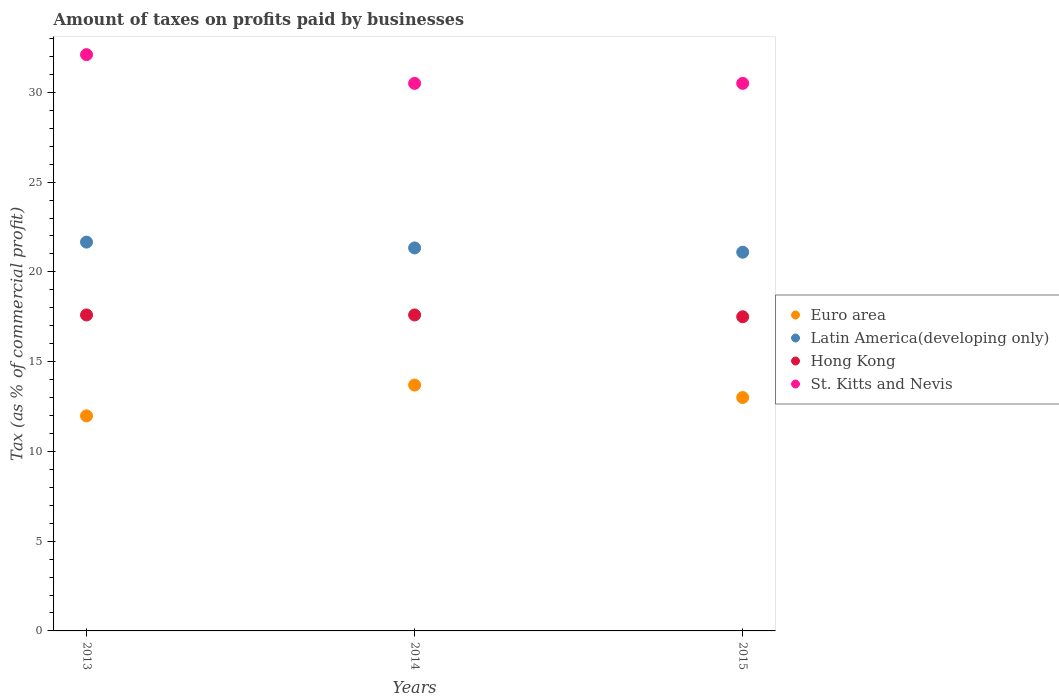Is the number of dotlines equal to the number of legend labels?
Offer a very short reply. Yes. Across all years, what is the maximum percentage of taxes paid by businesses in Latin America(developing only)?
Provide a succinct answer. 21.66. Across all years, what is the minimum percentage of taxes paid by businesses in Latin America(developing only)?
Provide a short and direct response. 21.1. In which year was the percentage of taxes paid by businesses in Latin America(developing only) maximum?
Your response must be concise. 2013. In which year was the percentage of taxes paid by businesses in Euro area minimum?
Offer a very short reply. 2013. What is the total percentage of taxes paid by businesses in Hong Kong in the graph?
Offer a very short reply. 52.7. What is the difference between the percentage of taxes paid by businesses in St. Kitts and Nevis in 2015 and the percentage of taxes paid by businesses in Latin America(developing only) in 2014?
Provide a short and direct response. 9.17. What is the average percentage of taxes paid by businesses in Hong Kong per year?
Offer a terse response. 17.57. In the year 2013, what is the difference between the percentage of taxes paid by businesses in Hong Kong and percentage of taxes paid by businesses in Euro area?
Your answer should be very brief. 5.62. In how many years, is the percentage of taxes paid by businesses in Euro area greater than 17 %?
Make the answer very short. 0. What is the ratio of the percentage of taxes paid by businesses in Hong Kong in 2014 to that in 2015?
Offer a very short reply. 1.01. Is the percentage of taxes paid by businesses in Hong Kong in 2013 less than that in 2014?
Ensure brevity in your answer.  No. What is the difference between the highest and the second highest percentage of taxes paid by businesses in Hong Kong?
Offer a terse response. 0. What is the difference between the highest and the lowest percentage of taxes paid by businesses in St. Kitts and Nevis?
Offer a very short reply. 1.6. In how many years, is the percentage of taxes paid by businesses in Hong Kong greater than the average percentage of taxes paid by businesses in Hong Kong taken over all years?
Provide a succinct answer. 2. Is it the case that in every year, the sum of the percentage of taxes paid by businesses in St. Kitts and Nevis and percentage of taxes paid by businesses in Hong Kong  is greater than the sum of percentage of taxes paid by businesses in Euro area and percentage of taxes paid by businesses in Latin America(developing only)?
Provide a short and direct response. Yes. How many dotlines are there?
Keep it short and to the point. 4. Does the graph contain grids?
Your response must be concise. No. How many legend labels are there?
Provide a short and direct response. 4. How are the legend labels stacked?
Provide a succinct answer. Vertical. What is the title of the graph?
Provide a short and direct response. Amount of taxes on profits paid by businesses. Does "Arab World" appear as one of the legend labels in the graph?
Your answer should be compact. No. What is the label or title of the Y-axis?
Make the answer very short. Tax (as % of commercial profit). What is the Tax (as % of commercial profit) in Euro area in 2013?
Offer a very short reply. 11.98. What is the Tax (as % of commercial profit) of Latin America(developing only) in 2013?
Provide a succinct answer. 21.66. What is the Tax (as % of commercial profit) of Hong Kong in 2013?
Your response must be concise. 17.6. What is the Tax (as % of commercial profit) of St. Kitts and Nevis in 2013?
Provide a succinct answer. 32.1. What is the Tax (as % of commercial profit) of Euro area in 2014?
Your answer should be compact. 13.69. What is the Tax (as % of commercial profit) of Latin America(developing only) in 2014?
Your response must be concise. 21.33. What is the Tax (as % of commercial profit) of St. Kitts and Nevis in 2014?
Your response must be concise. 30.5. What is the Tax (as % of commercial profit) of Euro area in 2015?
Your response must be concise. 13. What is the Tax (as % of commercial profit) in Latin America(developing only) in 2015?
Your answer should be compact. 21.1. What is the Tax (as % of commercial profit) of St. Kitts and Nevis in 2015?
Make the answer very short. 30.5. Across all years, what is the maximum Tax (as % of commercial profit) of Euro area?
Keep it short and to the point. 13.69. Across all years, what is the maximum Tax (as % of commercial profit) in Latin America(developing only)?
Offer a very short reply. 21.66. Across all years, what is the maximum Tax (as % of commercial profit) of St. Kitts and Nevis?
Your response must be concise. 32.1. Across all years, what is the minimum Tax (as % of commercial profit) in Euro area?
Make the answer very short. 11.98. Across all years, what is the minimum Tax (as % of commercial profit) of Latin America(developing only)?
Provide a short and direct response. 21.1. Across all years, what is the minimum Tax (as % of commercial profit) of Hong Kong?
Your answer should be very brief. 17.5. Across all years, what is the minimum Tax (as % of commercial profit) in St. Kitts and Nevis?
Provide a succinct answer. 30.5. What is the total Tax (as % of commercial profit) in Euro area in the graph?
Ensure brevity in your answer.  38.67. What is the total Tax (as % of commercial profit) of Latin America(developing only) in the graph?
Your answer should be very brief. 64.09. What is the total Tax (as % of commercial profit) of Hong Kong in the graph?
Keep it short and to the point. 52.7. What is the total Tax (as % of commercial profit) of St. Kitts and Nevis in the graph?
Your answer should be very brief. 93.1. What is the difference between the Tax (as % of commercial profit) in Euro area in 2013 and that in 2014?
Ensure brevity in your answer.  -1.72. What is the difference between the Tax (as % of commercial profit) in Latin America(developing only) in 2013 and that in 2014?
Make the answer very short. 0.32. What is the difference between the Tax (as % of commercial profit) in Euro area in 2013 and that in 2015?
Offer a very short reply. -1.02. What is the difference between the Tax (as % of commercial profit) in Latin America(developing only) in 2013 and that in 2015?
Your answer should be very brief. 0.56. What is the difference between the Tax (as % of commercial profit) in St. Kitts and Nevis in 2013 and that in 2015?
Your response must be concise. 1.6. What is the difference between the Tax (as % of commercial profit) of Euro area in 2014 and that in 2015?
Your response must be concise. 0.69. What is the difference between the Tax (as % of commercial profit) of Latin America(developing only) in 2014 and that in 2015?
Your response must be concise. 0.24. What is the difference between the Tax (as % of commercial profit) of St. Kitts and Nevis in 2014 and that in 2015?
Ensure brevity in your answer.  0. What is the difference between the Tax (as % of commercial profit) in Euro area in 2013 and the Tax (as % of commercial profit) in Latin America(developing only) in 2014?
Give a very brief answer. -9.35. What is the difference between the Tax (as % of commercial profit) in Euro area in 2013 and the Tax (as % of commercial profit) in Hong Kong in 2014?
Provide a succinct answer. -5.62. What is the difference between the Tax (as % of commercial profit) in Euro area in 2013 and the Tax (as % of commercial profit) in St. Kitts and Nevis in 2014?
Your answer should be very brief. -18.52. What is the difference between the Tax (as % of commercial profit) of Latin America(developing only) in 2013 and the Tax (as % of commercial profit) of Hong Kong in 2014?
Ensure brevity in your answer.  4.06. What is the difference between the Tax (as % of commercial profit) of Latin America(developing only) in 2013 and the Tax (as % of commercial profit) of St. Kitts and Nevis in 2014?
Offer a very short reply. -8.84. What is the difference between the Tax (as % of commercial profit) in Hong Kong in 2013 and the Tax (as % of commercial profit) in St. Kitts and Nevis in 2014?
Make the answer very short. -12.9. What is the difference between the Tax (as % of commercial profit) of Euro area in 2013 and the Tax (as % of commercial profit) of Latin America(developing only) in 2015?
Your answer should be very brief. -9.12. What is the difference between the Tax (as % of commercial profit) of Euro area in 2013 and the Tax (as % of commercial profit) of Hong Kong in 2015?
Your answer should be very brief. -5.52. What is the difference between the Tax (as % of commercial profit) in Euro area in 2013 and the Tax (as % of commercial profit) in St. Kitts and Nevis in 2015?
Give a very brief answer. -18.52. What is the difference between the Tax (as % of commercial profit) in Latin America(developing only) in 2013 and the Tax (as % of commercial profit) in Hong Kong in 2015?
Make the answer very short. 4.16. What is the difference between the Tax (as % of commercial profit) of Latin America(developing only) in 2013 and the Tax (as % of commercial profit) of St. Kitts and Nevis in 2015?
Provide a short and direct response. -8.84. What is the difference between the Tax (as % of commercial profit) of Euro area in 2014 and the Tax (as % of commercial profit) of Latin America(developing only) in 2015?
Ensure brevity in your answer.  -7.4. What is the difference between the Tax (as % of commercial profit) of Euro area in 2014 and the Tax (as % of commercial profit) of Hong Kong in 2015?
Provide a succinct answer. -3.81. What is the difference between the Tax (as % of commercial profit) in Euro area in 2014 and the Tax (as % of commercial profit) in St. Kitts and Nevis in 2015?
Provide a succinct answer. -16.81. What is the difference between the Tax (as % of commercial profit) of Latin America(developing only) in 2014 and the Tax (as % of commercial profit) of Hong Kong in 2015?
Keep it short and to the point. 3.83. What is the difference between the Tax (as % of commercial profit) in Latin America(developing only) in 2014 and the Tax (as % of commercial profit) in St. Kitts and Nevis in 2015?
Keep it short and to the point. -9.17. What is the difference between the Tax (as % of commercial profit) of Hong Kong in 2014 and the Tax (as % of commercial profit) of St. Kitts and Nevis in 2015?
Your answer should be compact. -12.9. What is the average Tax (as % of commercial profit) of Euro area per year?
Keep it short and to the point. 12.89. What is the average Tax (as % of commercial profit) in Latin America(developing only) per year?
Your answer should be very brief. 21.36. What is the average Tax (as % of commercial profit) in Hong Kong per year?
Provide a succinct answer. 17.57. What is the average Tax (as % of commercial profit) of St. Kitts and Nevis per year?
Offer a very short reply. 31.03. In the year 2013, what is the difference between the Tax (as % of commercial profit) of Euro area and Tax (as % of commercial profit) of Latin America(developing only)?
Give a very brief answer. -9.68. In the year 2013, what is the difference between the Tax (as % of commercial profit) of Euro area and Tax (as % of commercial profit) of Hong Kong?
Offer a very short reply. -5.62. In the year 2013, what is the difference between the Tax (as % of commercial profit) of Euro area and Tax (as % of commercial profit) of St. Kitts and Nevis?
Provide a succinct answer. -20.12. In the year 2013, what is the difference between the Tax (as % of commercial profit) in Latin America(developing only) and Tax (as % of commercial profit) in Hong Kong?
Ensure brevity in your answer.  4.06. In the year 2013, what is the difference between the Tax (as % of commercial profit) of Latin America(developing only) and Tax (as % of commercial profit) of St. Kitts and Nevis?
Keep it short and to the point. -10.44. In the year 2013, what is the difference between the Tax (as % of commercial profit) of Hong Kong and Tax (as % of commercial profit) of St. Kitts and Nevis?
Keep it short and to the point. -14.5. In the year 2014, what is the difference between the Tax (as % of commercial profit) of Euro area and Tax (as % of commercial profit) of Latin America(developing only)?
Your answer should be compact. -7.64. In the year 2014, what is the difference between the Tax (as % of commercial profit) in Euro area and Tax (as % of commercial profit) in Hong Kong?
Your answer should be very brief. -3.91. In the year 2014, what is the difference between the Tax (as % of commercial profit) in Euro area and Tax (as % of commercial profit) in St. Kitts and Nevis?
Ensure brevity in your answer.  -16.81. In the year 2014, what is the difference between the Tax (as % of commercial profit) of Latin America(developing only) and Tax (as % of commercial profit) of Hong Kong?
Your answer should be compact. 3.73. In the year 2014, what is the difference between the Tax (as % of commercial profit) of Latin America(developing only) and Tax (as % of commercial profit) of St. Kitts and Nevis?
Your response must be concise. -9.17. In the year 2014, what is the difference between the Tax (as % of commercial profit) of Hong Kong and Tax (as % of commercial profit) of St. Kitts and Nevis?
Offer a terse response. -12.9. In the year 2015, what is the difference between the Tax (as % of commercial profit) of Euro area and Tax (as % of commercial profit) of Latin America(developing only)?
Your response must be concise. -8.1. In the year 2015, what is the difference between the Tax (as % of commercial profit) in Euro area and Tax (as % of commercial profit) in St. Kitts and Nevis?
Provide a short and direct response. -17.5. In the year 2015, what is the difference between the Tax (as % of commercial profit) in Latin America(developing only) and Tax (as % of commercial profit) in Hong Kong?
Offer a terse response. 3.6. In the year 2015, what is the difference between the Tax (as % of commercial profit) of Latin America(developing only) and Tax (as % of commercial profit) of St. Kitts and Nevis?
Offer a terse response. -9.4. In the year 2015, what is the difference between the Tax (as % of commercial profit) of Hong Kong and Tax (as % of commercial profit) of St. Kitts and Nevis?
Offer a very short reply. -13. What is the ratio of the Tax (as % of commercial profit) in Euro area in 2013 to that in 2014?
Provide a short and direct response. 0.87. What is the ratio of the Tax (as % of commercial profit) in Latin America(developing only) in 2013 to that in 2014?
Offer a terse response. 1.02. What is the ratio of the Tax (as % of commercial profit) in Hong Kong in 2013 to that in 2014?
Your answer should be very brief. 1. What is the ratio of the Tax (as % of commercial profit) of St. Kitts and Nevis in 2013 to that in 2014?
Your answer should be very brief. 1.05. What is the ratio of the Tax (as % of commercial profit) in Euro area in 2013 to that in 2015?
Ensure brevity in your answer.  0.92. What is the ratio of the Tax (as % of commercial profit) of Latin America(developing only) in 2013 to that in 2015?
Your answer should be very brief. 1.03. What is the ratio of the Tax (as % of commercial profit) of St. Kitts and Nevis in 2013 to that in 2015?
Offer a very short reply. 1.05. What is the ratio of the Tax (as % of commercial profit) in Euro area in 2014 to that in 2015?
Your response must be concise. 1.05. What is the ratio of the Tax (as % of commercial profit) of Latin America(developing only) in 2014 to that in 2015?
Your response must be concise. 1.01. What is the ratio of the Tax (as % of commercial profit) in St. Kitts and Nevis in 2014 to that in 2015?
Provide a succinct answer. 1. What is the difference between the highest and the second highest Tax (as % of commercial profit) in Euro area?
Offer a very short reply. 0.69. What is the difference between the highest and the second highest Tax (as % of commercial profit) of Latin America(developing only)?
Your answer should be very brief. 0.32. What is the difference between the highest and the lowest Tax (as % of commercial profit) of Euro area?
Make the answer very short. 1.72. What is the difference between the highest and the lowest Tax (as % of commercial profit) in Latin America(developing only)?
Ensure brevity in your answer.  0.56. What is the difference between the highest and the lowest Tax (as % of commercial profit) of Hong Kong?
Ensure brevity in your answer.  0.1. What is the difference between the highest and the lowest Tax (as % of commercial profit) in St. Kitts and Nevis?
Provide a succinct answer. 1.6. 